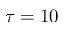Convert formula to latex. <formula><loc_0><loc_0><loc_500><loc_500>\tau = 1 0</formula> 